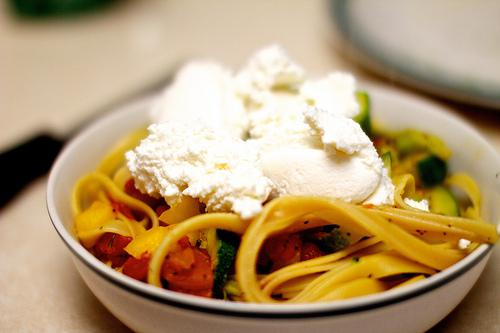Question: what is the picture of?
Choices:
A. Balloons.
B. Bowling pins.
C. Shoes.
D. Food.
Answer with the letter. Answer: D Question: what is the food in?
Choices:
A. A plate.
B. A bowl.
C. A plastic bag.
D. A cup.
Answer with the letter. Answer: B Question: what wheat is in the dish?
Choices:
A. Noodles.
B. Semolina.
C. Cream of wheat.
D. Whole wheat.
Answer with the letter. Answer: A Question: how many bowls are pictured?
Choices:
A. 2.
B. 3.
C. 1.
D. 4.
Answer with the letter. Answer: C Question: who is in the picture?
Choices:
A. A man.
B. A woman.
C. A family.
D. No one.
Answer with the letter. Answer: D Question: what color are the noodles?
Choices:
A. Yellow.
B. White.
C. Tan.
D. Gray.
Answer with the letter. Answer: C 